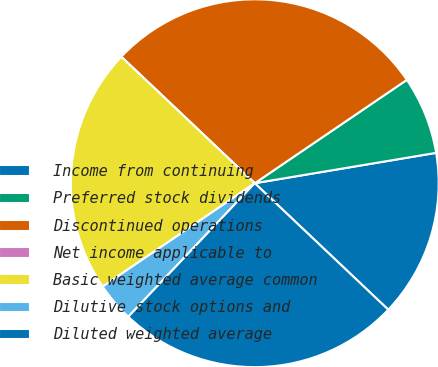Convert chart to OTSL. <chart><loc_0><loc_0><loc_500><loc_500><pie_chart><fcel>Income from continuing<fcel>Preferred stock dividends<fcel>Discontinued operations<fcel>Net income applicable to<fcel>Basic weighted average common<fcel>Dilutive stock options and<fcel>Diluted weighted average<nl><fcel>14.71%<fcel>6.86%<fcel>28.43%<fcel>0.0%<fcel>21.57%<fcel>3.43%<fcel>25.0%<nl></chart> 